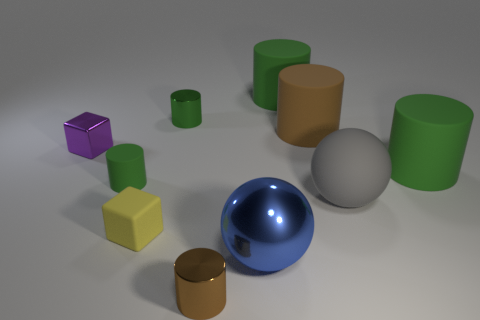Subtract all purple blocks. How many green cylinders are left? 4 Subtract all tiny green cylinders. How many cylinders are left? 4 Subtract all brown cylinders. How many cylinders are left? 4 Subtract all blue cylinders. Subtract all red balls. How many cylinders are left? 6 Subtract all balls. How many objects are left? 8 Subtract all big blue spheres. Subtract all brown metal balls. How many objects are left? 9 Add 4 big gray matte balls. How many big gray matte balls are left? 5 Add 5 tiny yellow blocks. How many tiny yellow blocks exist? 6 Subtract 0 blue cubes. How many objects are left? 10 